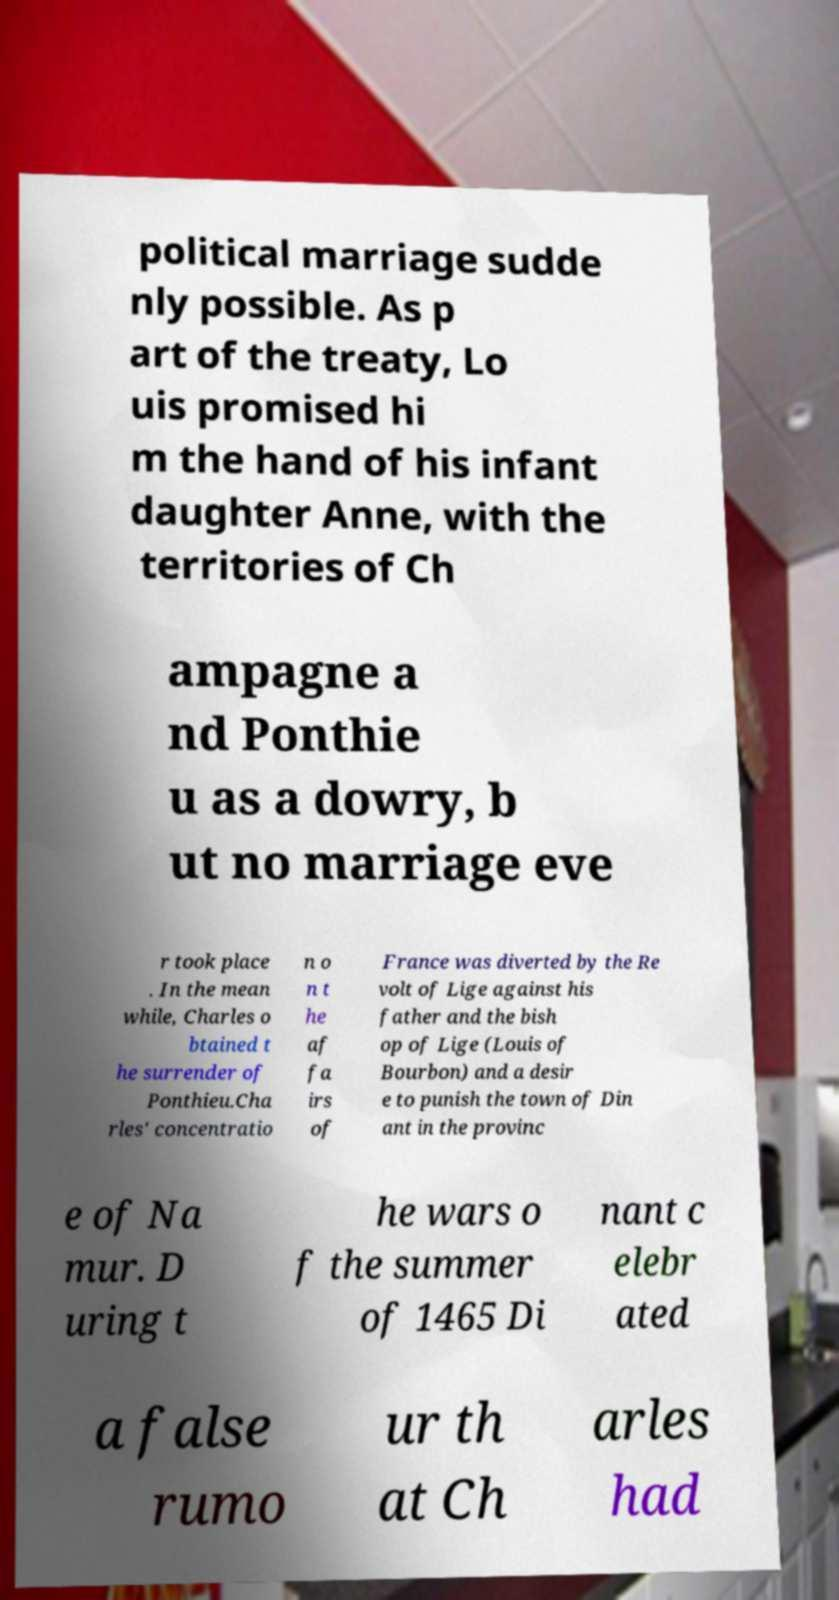There's text embedded in this image that I need extracted. Can you transcribe it verbatim? political marriage sudde nly possible. As p art of the treaty, Lo uis promised hi m the hand of his infant daughter Anne, with the territories of Ch ampagne a nd Ponthie u as a dowry, b ut no marriage eve r took place . In the mean while, Charles o btained t he surrender of Ponthieu.Cha rles' concentratio n o n t he af fa irs of France was diverted by the Re volt of Lige against his father and the bish op of Lige (Louis of Bourbon) and a desir e to punish the town of Din ant in the provinc e of Na mur. D uring t he wars o f the summer of 1465 Di nant c elebr ated a false rumo ur th at Ch arles had 